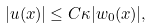<formula> <loc_0><loc_0><loc_500><loc_500>| u ( x ) | \leq C \kappa | w _ { 0 } ( x ) | ,</formula> 